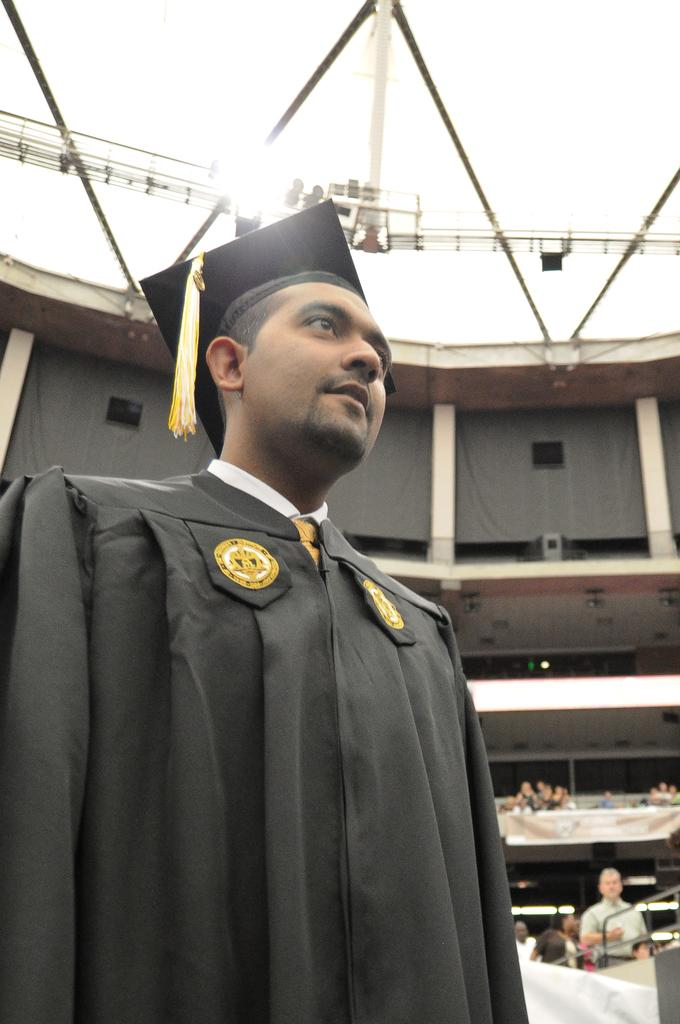Who is present in the image? There is a person in the image. What is the person wearing? The person is wearing a graduation dress and a hat. What can be seen in the background of the image? There is a building in the background of the image. What type of haircut does the person have in the image? The provided facts do not mention the person's haircut, so we cannot determine it from the image. 